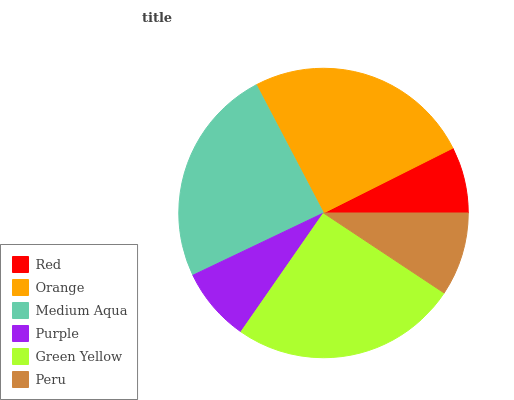Is Red the minimum?
Answer yes or no. Yes. Is Green Yellow the maximum?
Answer yes or no. Yes. Is Orange the minimum?
Answer yes or no. No. Is Orange the maximum?
Answer yes or no. No. Is Orange greater than Red?
Answer yes or no. Yes. Is Red less than Orange?
Answer yes or no. Yes. Is Red greater than Orange?
Answer yes or no. No. Is Orange less than Red?
Answer yes or no. No. Is Medium Aqua the high median?
Answer yes or no. Yes. Is Peru the low median?
Answer yes or no. Yes. Is Peru the high median?
Answer yes or no. No. Is Purple the low median?
Answer yes or no. No. 